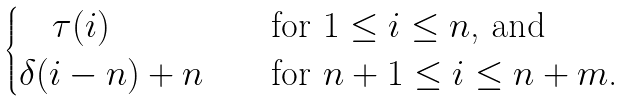Convert formula to latex. <formula><loc_0><loc_0><loc_500><loc_500>\begin{cases} \quad \tau ( i ) & \text {\quad for $1\leq i\leq n$, and} \\ \delta ( i - n ) + n & \text {\quad for $n+1\leq i\leq n+m$.} \end{cases}</formula> 